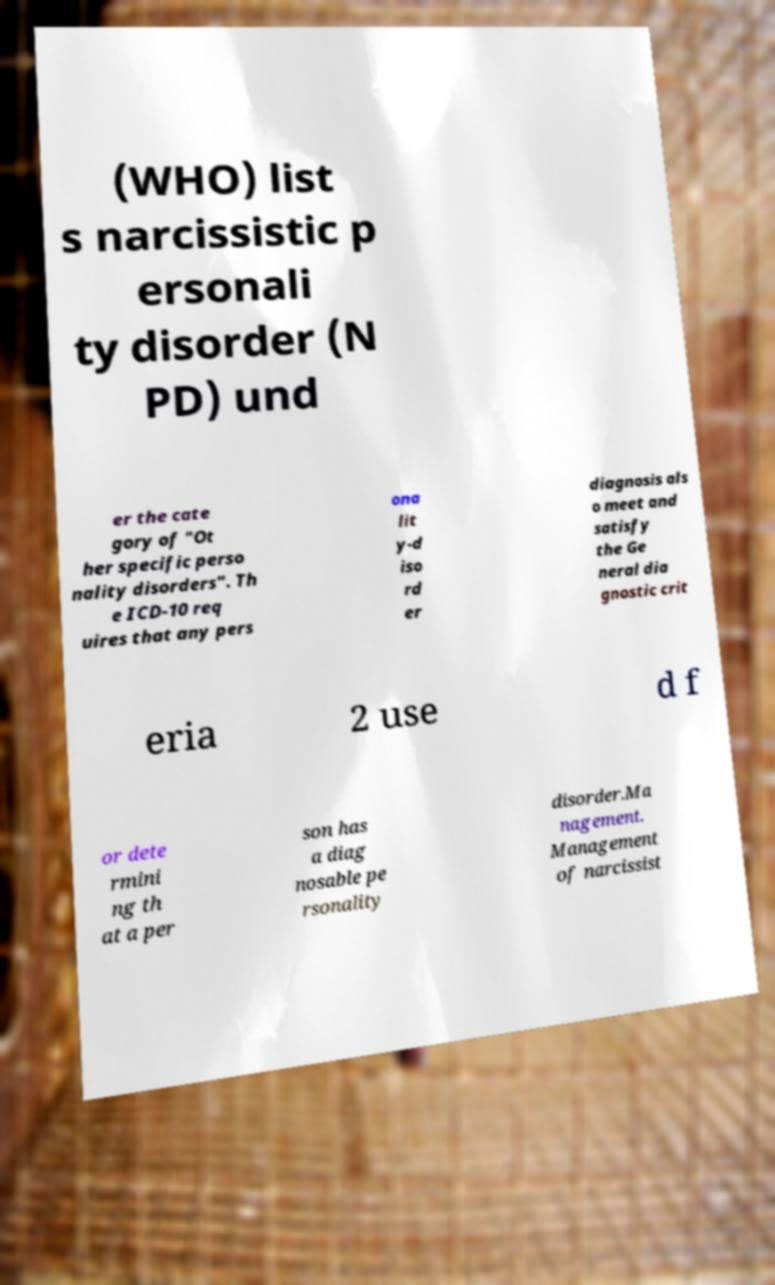Please read and relay the text visible in this image. What does it say? (WHO) list s narcissistic p ersonali ty disorder (N PD) und er the cate gory of "Ot her specific perso nality disorders". Th e ICD-10 req uires that any pers ona lit y-d iso rd er diagnosis als o meet and satisfy the Ge neral dia gnostic crit eria 2 use d f or dete rmini ng th at a per son has a diag nosable pe rsonality disorder.Ma nagement. Management of narcissist 